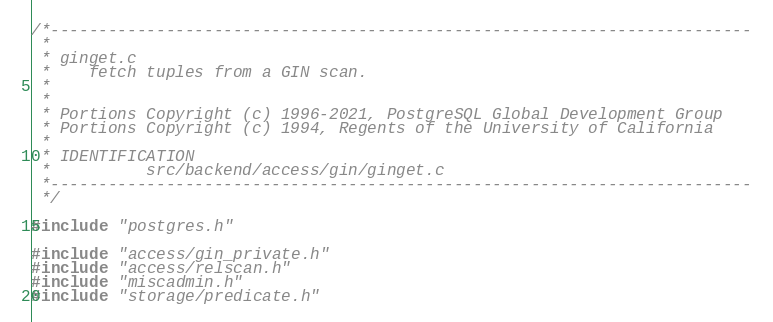<code> <loc_0><loc_0><loc_500><loc_500><_C_>/*-------------------------------------------------------------------------
 *
 * ginget.c
 *	  fetch tuples from a GIN scan.
 *
 *
 * Portions Copyright (c) 1996-2021, PostgreSQL Global Development Group
 * Portions Copyright (c) 1994, Regents of the University of California
 *
 * IDENTIFICATION
 *			src/backend/access/gin/ginget.c
 *-------------------------------------------------------------------------
 */

#include "postgres.h"

#include "access/gin_private.h"
#include "access/relscan.h"
#include "miscadmin.h"
#include "storage/predicate.h"</code> 